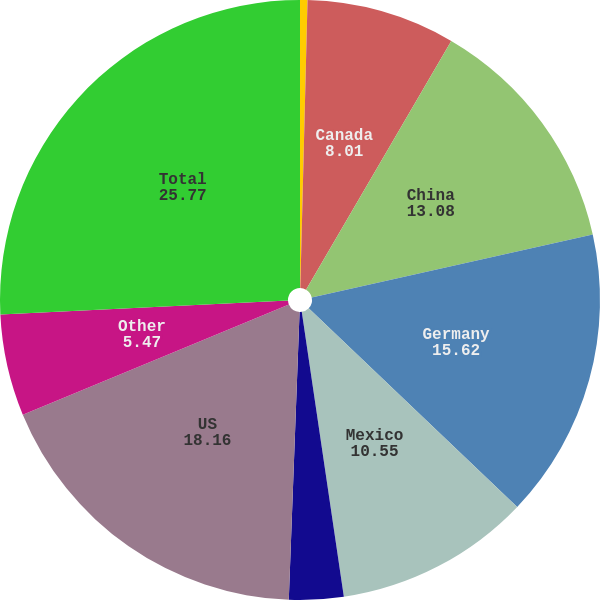<chart> <loc_0><loc_0><loc_500><loc_500><pie_chart><fcel>Belgium<fcel>Canada<fcel>China<fcel>Germany<fcel>Mexico<fcel>Singapore<fcel>US<fcel>Other<fcel>Total<nl><fcel>0.4%<fcel>8.01%<fcel>13.08%<fcel>15.62%<fcel>10.55%<fcel>2.93%<fcel>18.16%<fcel>5.47%<fcel>25.77%<nl></chart> 